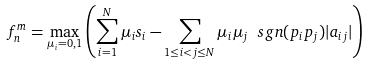Convert formula to latex. <formula><loc_0><loc_0><loc_500><loc_500>f ^ { m } _ { n } = \max _ { \mu _ { i } = 0 , 1 } \left ( \sum _ { i = 1 } ^ { N } \mu _ { i } s _ { i } - \sum _ { 1 \leq i < j \leq N } \mu _ { i } \mu _ { j } \ s g n ( p _ { i } p _ { j } ) | a _ { i j } | \right )</formula> 